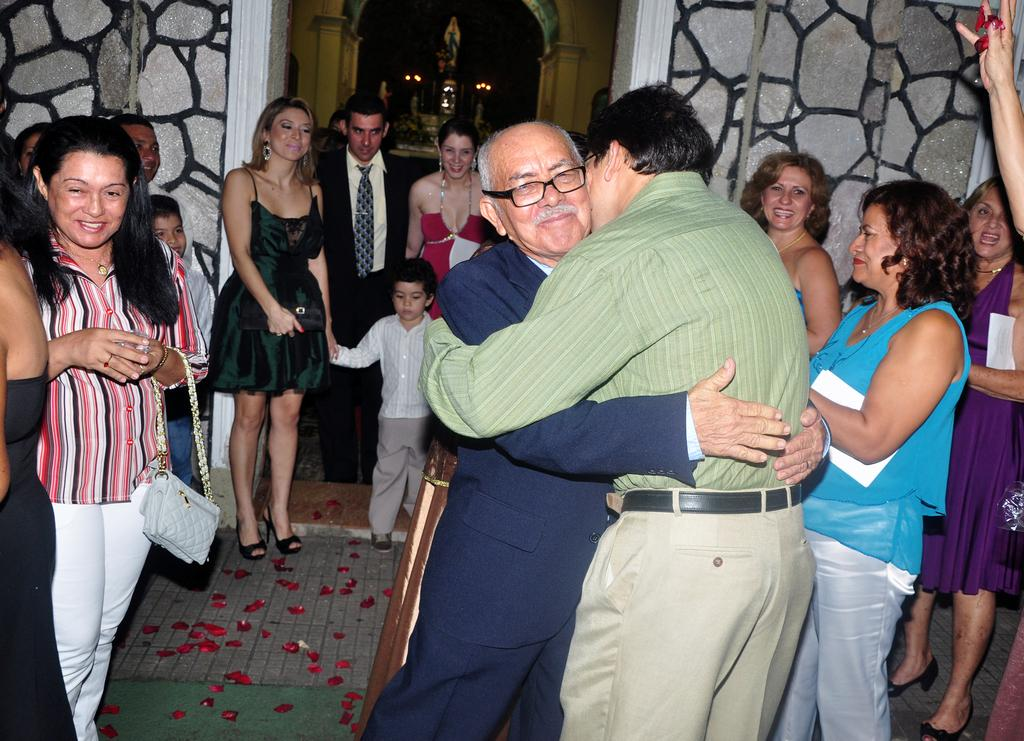What can be seen in the image involving a group of people? There is a group of people standing in the image. What type of architectural features are visible in the image? Walls and an arch are visible in the image. Can you describe any other objects present in the image? There are other objects present in the image, but their specific details are not mentioned in the provided facts. How many blades are visible in the image? There is no mention of blades in the provided facts, so it cannot be determined from the image. What type of knot is being tied by the people in the image? There is no indication of any knot-tying activity in the image. 